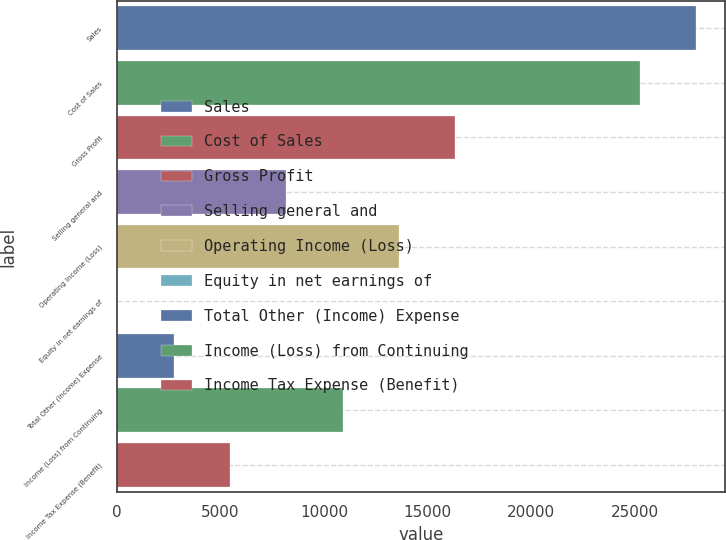Convert chart to OTSL. <chart><loc_0><loc_0><loc_500><loc_500><bar_chart><fcel>Sales<fcel>Cost of Sales<fcel>Gross Profit<fcel>Selling general and<fcel>Operating Income (Loss)<fcel>Equity in net earnings of<fcel>Total Other (Income) Expense<fcel>Income (Loss) from Continuing<fcel>Income Tax Expense (Benefit)<nl><fcel>27966.1<fcel>25244<fcel>16343.6<fcel>8177.3<fcel>13621.5<fcel>11<fcel>2733.1<fcel>10899.4<fcel>5455.2<nl></chart> 